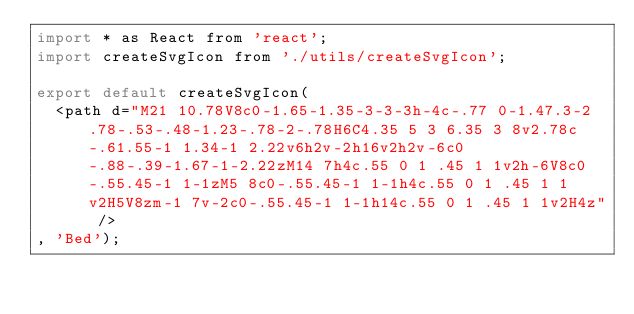Convert code to text. <code><loc_0><loc_0><loc_500><loc_500><_JavaScript_>import * as React from 'react';
import createSvgIcon from './utils/createSvgIcon';

export default createSvgIcon(
  <path d="M21 10.78V8c0-1.65-1.35-3-3-3h-4c-.77 0-1.47.3-2 .78-.53-.48-1.23-.78-2-.78H6C4.35 5 3 6.35 3 8v2.78c-.61.55-1 1.34-1 2.22v6h2v-2h16v2h2v-6c0-.88-.39-1.67-1-2.22zM14 7h4c.55 0 1 .45 1 1v2h-6V8c0-.55.45-1 1-1zM5 8c0-.55.45-1 1-1h4c.55 0 1 .45 1 1v2H5V8zm-1 7v-2c0-.55.45-1 1-1h14c.55 0 1 .45 1 1v2H4z" />
, 'Bed');
</code> 